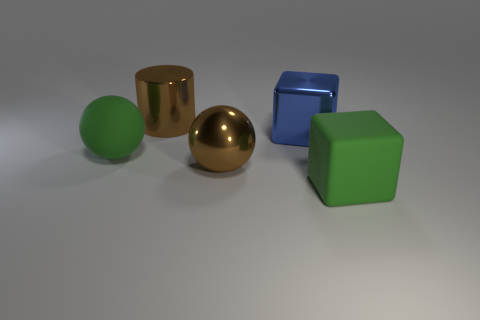Add 4 small green metallic cubes. How many objects exist? 9 Subtract all cubes. How many objects are left? 3 Add 2 blue shiny blocks. How many blue shiny blocks exist? 3 Subtract 0 yellow cylinders. How many objects are left? 5 Subtract all brown cylinders. Subtract all large blue metallic cubes. How many objects are left? 3 Add 2 big brown balls. How many big brown balls are left? 3 